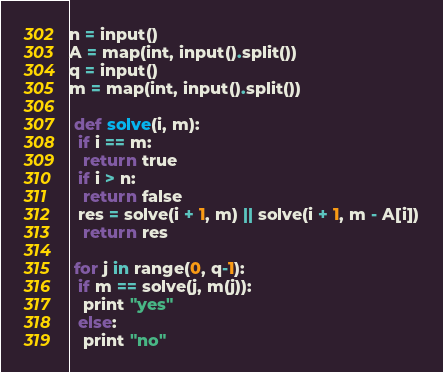<code> <loc_0><loc_0><loc_500><loc_500><_Python_>n = input()
A = map(int, input().split())
q = input()
m = map(int, input().split())

 def solve(i, m):
  if i == m:
   return true
  if i > n:
   return false
  res = solve(i + 1, m) || solve(i + 1, m - A[i])
   return res
 
 for j in range(0, q-1):
  if m == solve(j, m(j)):
   print "yes"
  else:
   print "no"</code> 